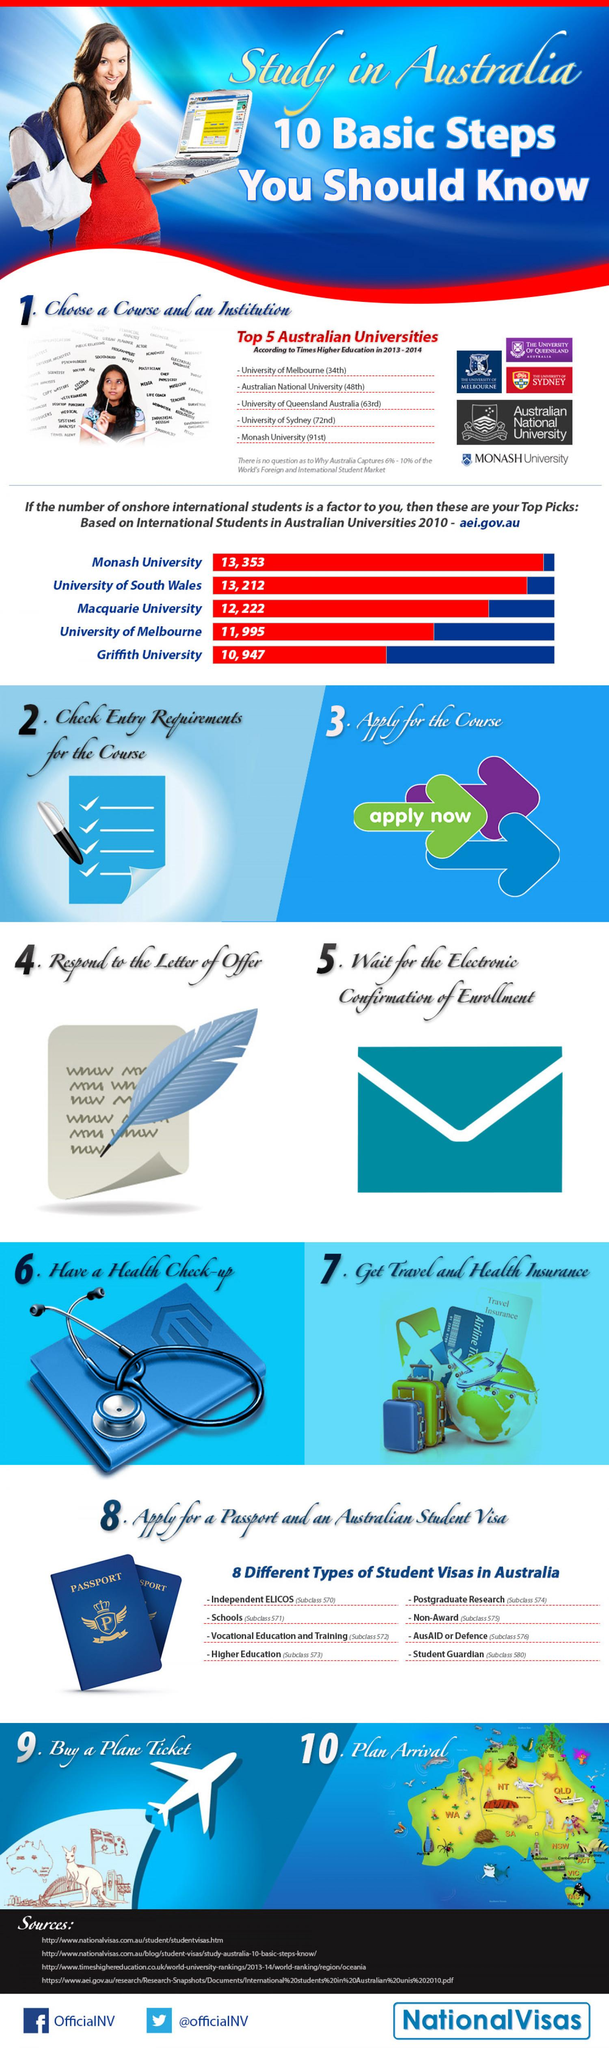Identify some key points in this picture. Macquarie University is ranked third among the top five Australian universities in terms of international students in 2010. Among the top 5 Australian universities based on enrollment of international students in 2010, the University of Melbourne ranked fourth. Griffith University is ranked fifth among the top five Australian universities in terms of the number of international students enrolled in 2010. According to the Top 5 Australian universities based on international students in 2010, the University of South Wales came in second. In 2013-2014, the University of Sydney was ranked fourth among the top five universities in Australia, according to Times Higher Education. 